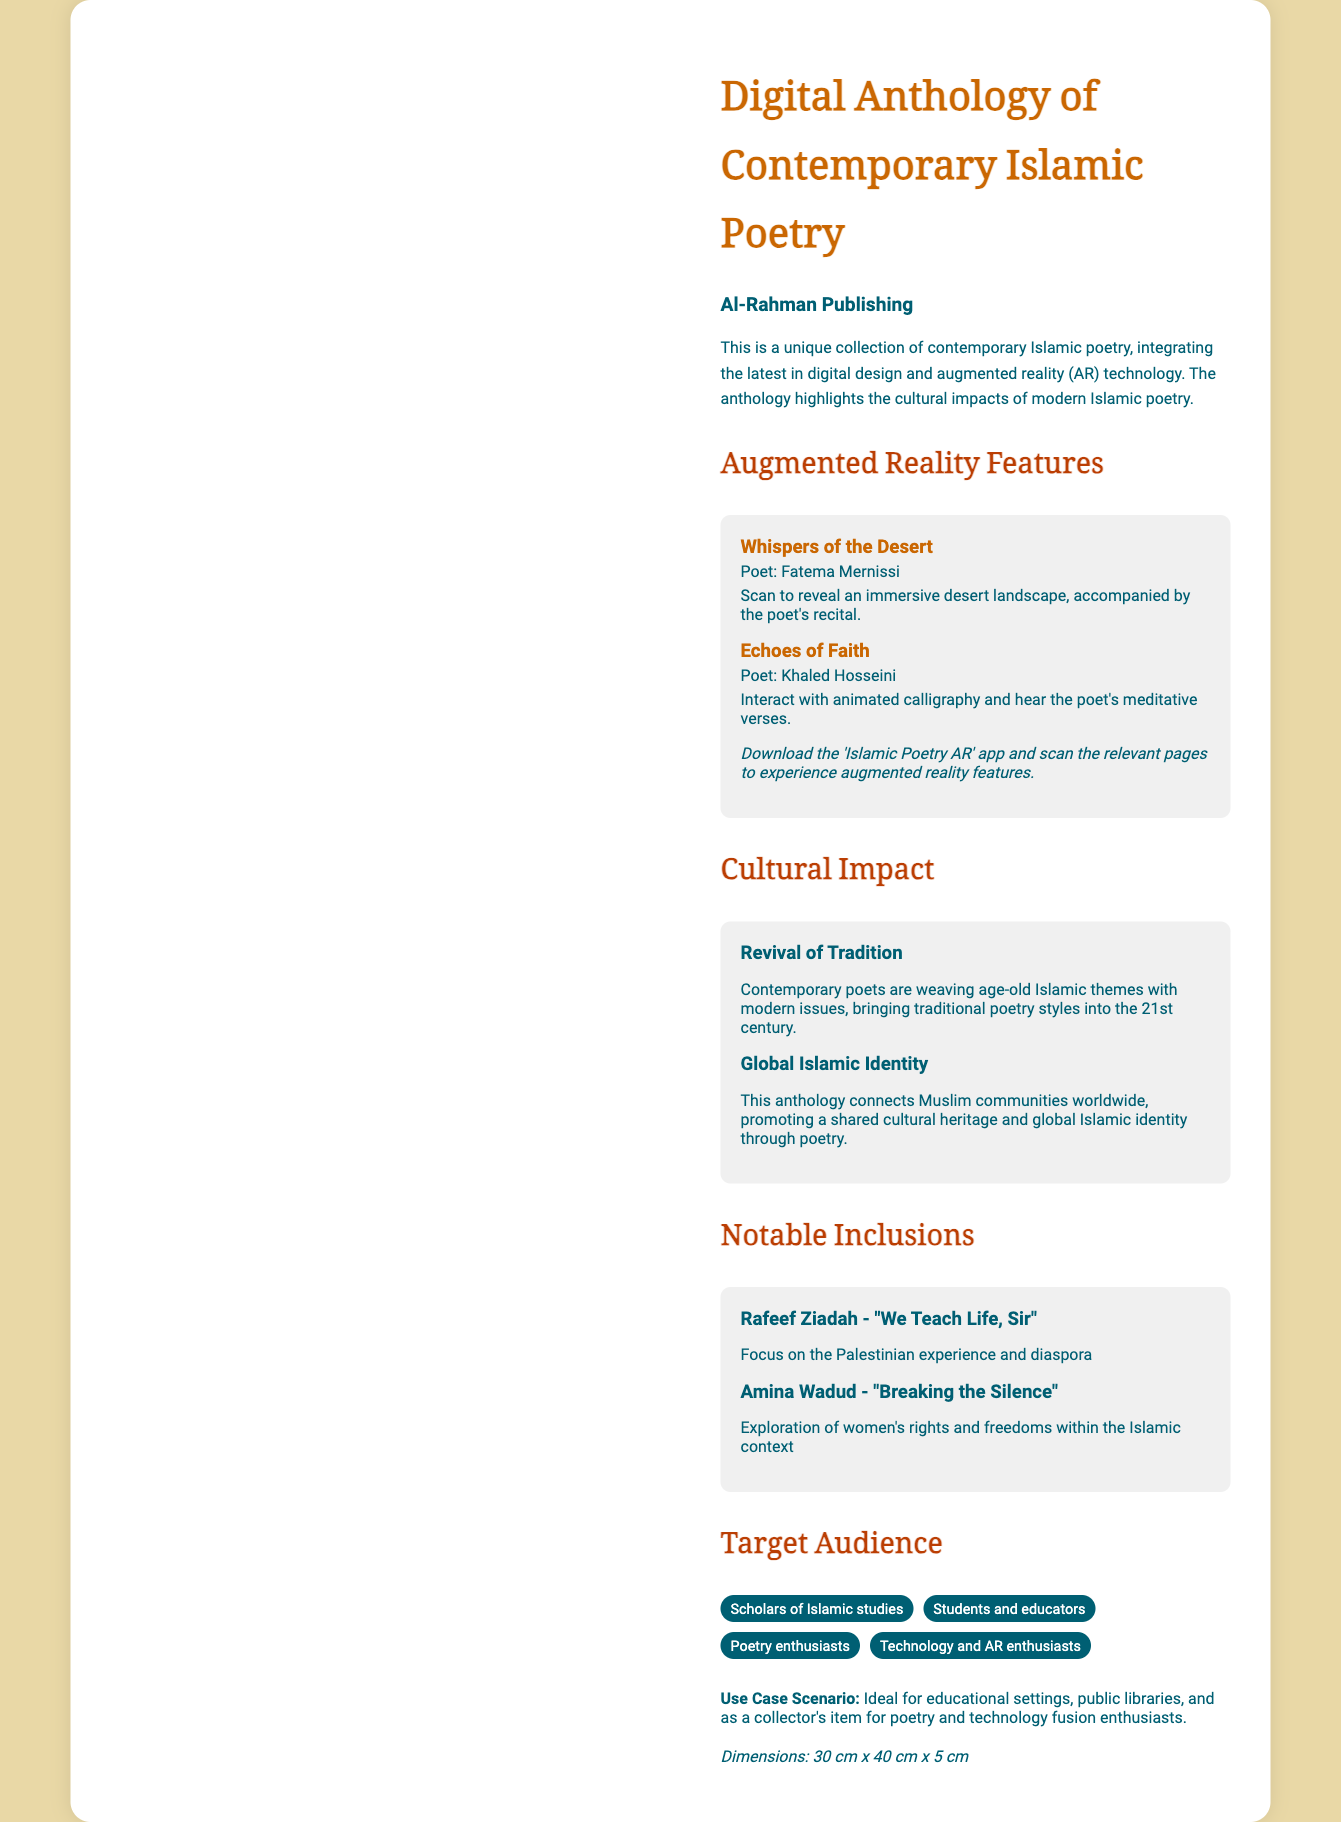What is the title of the anthology? The title of the anthology is stated prominently at the top of the document.
Answer: Digital Anthology of Contemporary Islamic Poetry Who is the publisher of the anthology? The brand or publisher of the anthology is mentioned in the document.
Answer: Al-Rahman Publishing What features technology does the anthology incorporate? The document specifically mentions the technology integrated into the anthology.
Answer: Augmented reality (AR) technology Name one poet featured in the augmented reality section. The document lists specific poets in the AR features section.
Answer: Fatema Mernissi What theme does Rafeef Ziadah's poem address? The thematic focus of Rafeef Ziadah's notable poem is provided in the text.
Answer: Palestinian experience and diaspora How many notable inclusions are mentioned in the document? The document provides a direct count of notable inclusions listed.
Answer: Two What is the dimensions of the anthology? The dimensions of the anthology are specified at the end of the document.
Answer: 30 cm x 40 cm x 5 cm Which audience is specifically targeted by this anthology? The target audience section lists specific groups.
Answer: Scholars of Islamic studies What is the purpose of including augmented reality features? The document suggests a reason for integrating AR features in the anthology.
Answer: Cultural impacts of modern Islamic poetry 